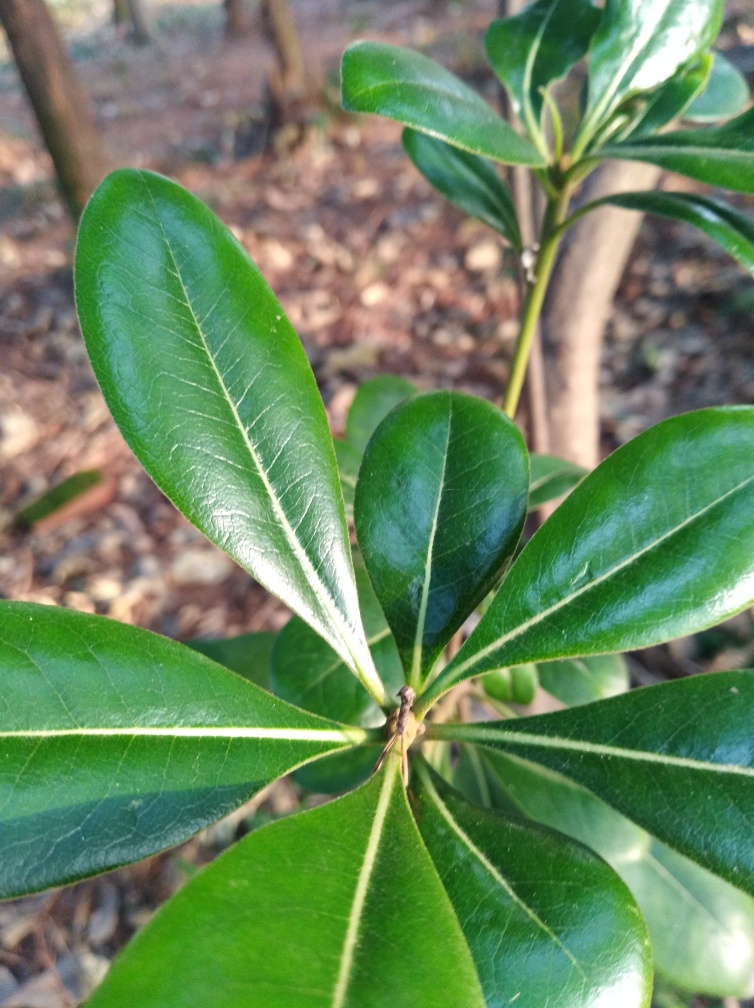Can you tell me more about the health of this plant? The plant in the image seems healthy. The leaves are lush, green, and free of spots or blemishes that would typically indicate disease or environmental stress. What could cause the leaves to change color or deteriorate? Several factors could lead to color changes or deterioration in leaves, including nutrient deficiencies, water stress, pest infestations, or fungal diseases. Proper care and regular monitoring can usually prevent or mitigate these issues. 